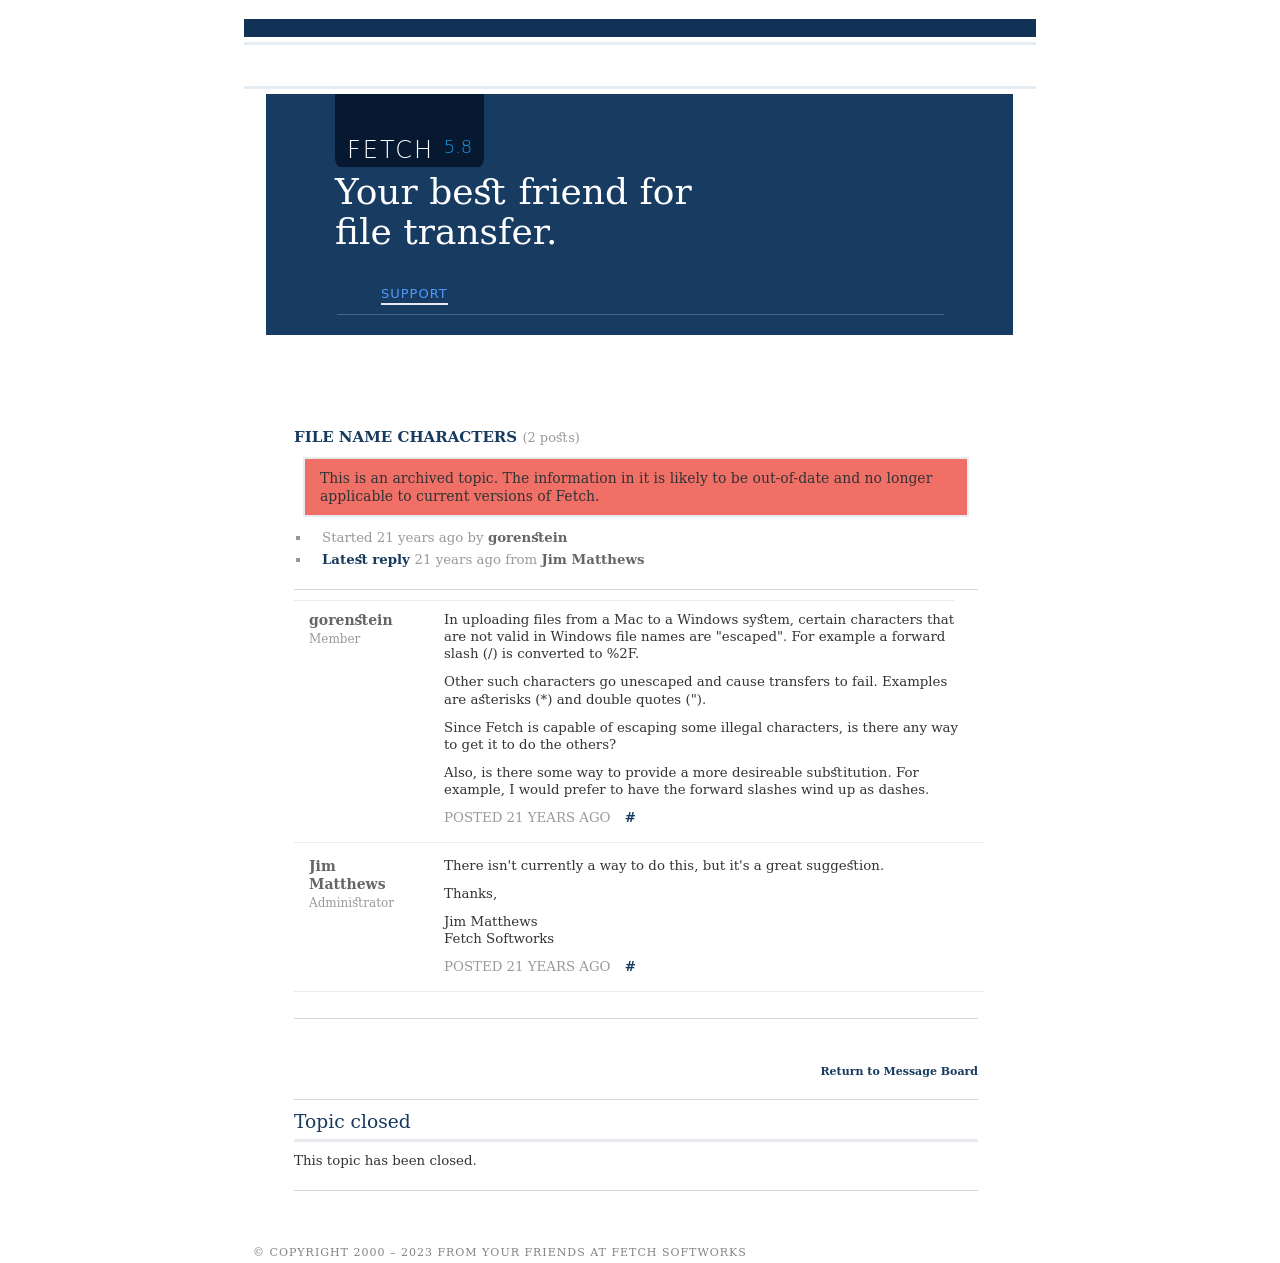What's the procedure for constructing this website from scratch with HTML? To construct a website similar to the one displayed in the image, which features a forum layout for software support, you'll begin by establishing the basic structure with HTML. Start by defining the HTML5 doctype and creating a container for the header, main content area, and footer. Use semantic tags such as <header>, <main>, <section>, and <footer> for better structure and accessibility. In your <head> section, link to CSS for styling and ensure to define styles for general layout, typography, and responsive design to accommodate different devices. Importantly, include forms for user interaction and possibly JavaScript to handle interactive elements like search functionality and form submission. Here's a simple example setup:

<!DOCTYPE html>
<html lang='en'>
<head>
   <meta charset='UTF-8'>
   <meta name='viewport' content='width=device-width, initial-scale=1.0'>
   <title>Fetch Support Forum</title>
   <link rel='stylesheet' href='styles.css'>
</head>
<body>
   <header>
       <h1>Fetch Support Forum</h1>
   </header>
   <main>
       <section>
           <article>
               <h2>File Name Characters</h2>
               <p>Discussion content here...</p>
           </article>
       </section>
   </main>
   <footer>
       <p>© 2023 Fetch Softworks</p>
   </footer>
</body>
</html>

This foundational HTML provides a barebone structure, with external CSS handling all stylistic elements, making the page visually appealing and functionally robust. 